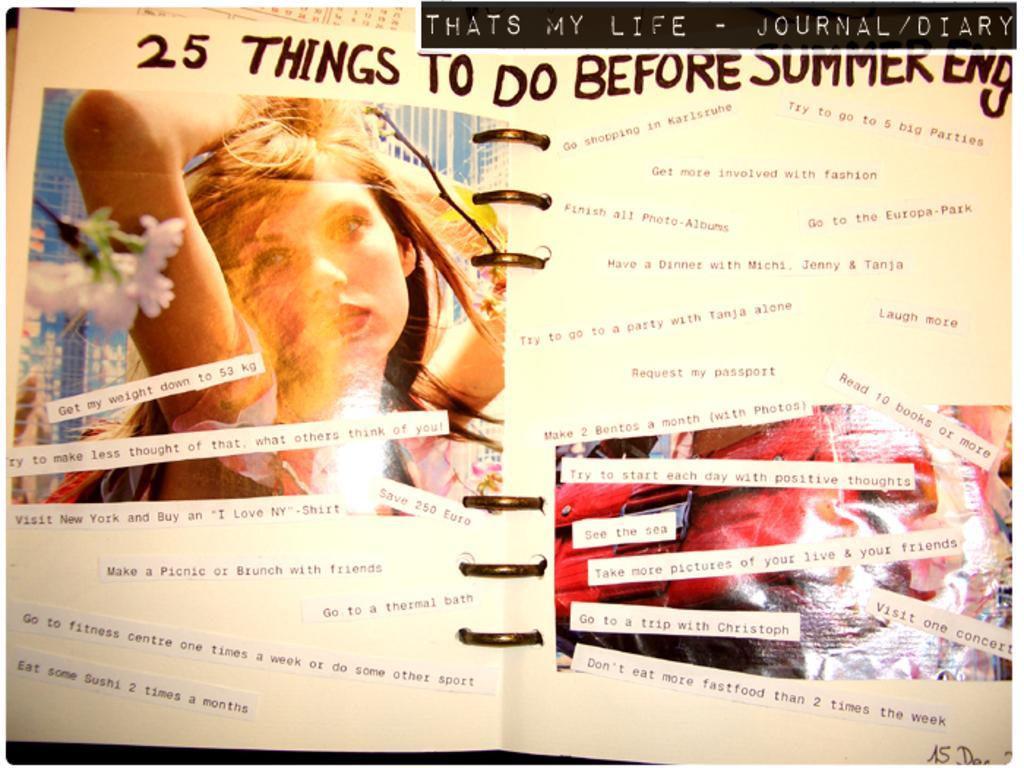In one or two sentences, can you explain what this image depicts? This image consists of a book. In that there are so many things pasted. This looks like a spiral book. There is a picture of the woman on the left side. 